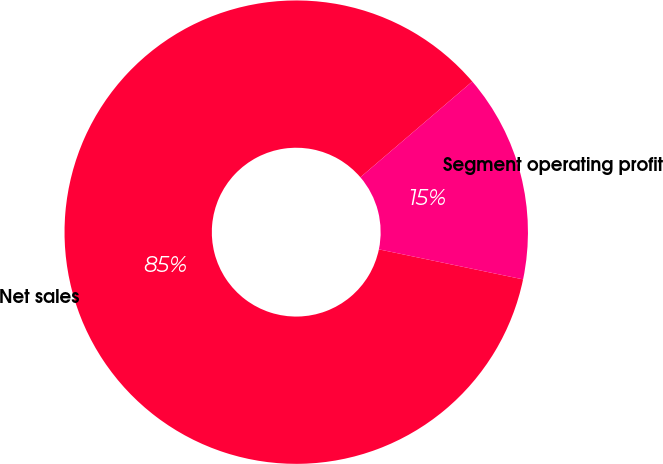Convert chart. <chart><loc_0><loc_0><loc_500><loc_500><pie_chart><fcel>Net sales<fcel>Segment operating profit<nl><fcel>85.47%<fcel>14.53%<nl></chart> 